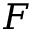<formula> <loc_0><loc_0><loc_500><loc_500>F</formula> 